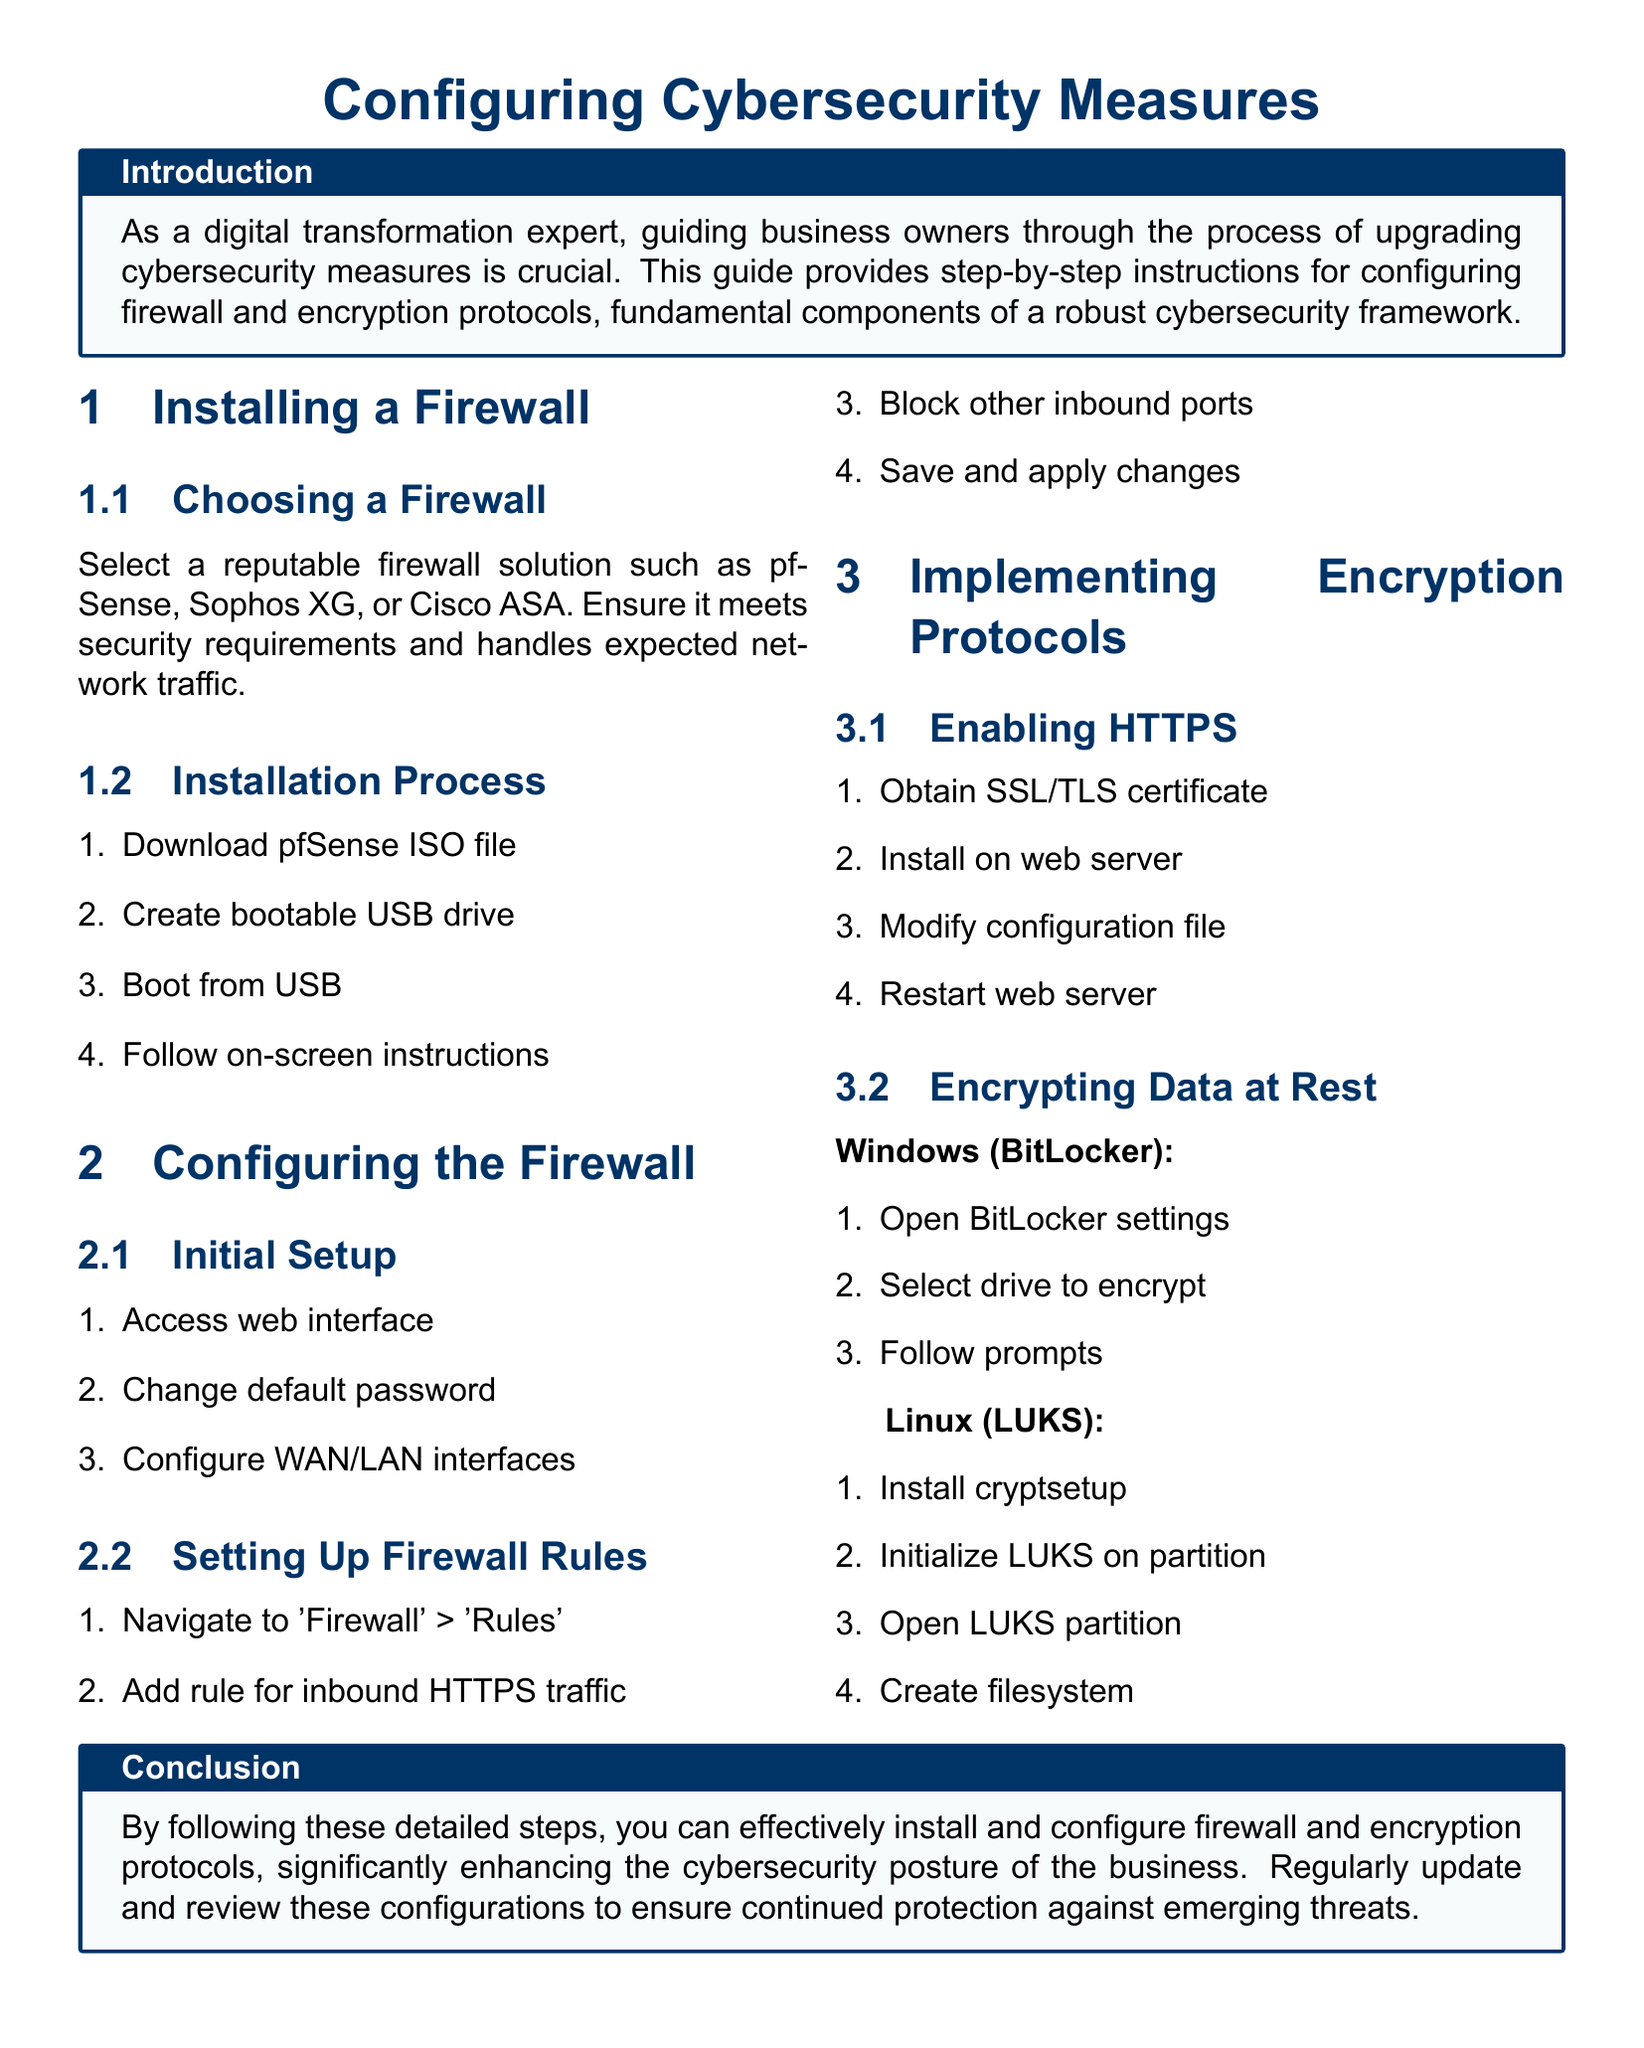What is the title of the document? The title of the document is presented in the header section, which states "Configuring Cybersecurity Measures."
Answer: Configuring Cybersecurity Measures What is the first step to install a firewall? The first step in the installation process listed in the document is to download the pfSense ISO file.
Answer: Download pfSense ISO file Which firewall solutions are recommended? The document mentions several recommended firewall solutions, specifically pfSense, Sophos XG, and Cisco ASA.
Answer: pfSense, Sophos XG, Cisco ASA What is required to enable HTTPS? To enable HTTPS, it is necessary to obtain an SSL/TLS certificate as stated in the section about implementing encryption protocols.
Answer: SSL/TLS certificate How do you encrypt data at rest on Windows? The section on encrypting data at rest specifies using BitLocker and provides steps for it, which includes opening BitLocker settings.
Answer: Open BitLocker settings What do you need to do after modifying the configuration file for HTTPS? The document states that after modifying the configuration file, you need to restart the web server.
Answer: Restart web server What does the document suggest for regular maintenance? The conclusion suggests regularly updating and reviewing configurations to protect against emerging threats.
Answer: Regularly update and review configurations What is the final step in creating a filesystem after opening the LUKS partition? The document indicates that the final step is to create a filesystem after opening a LUKS partition.
Answer: Create filesystem 